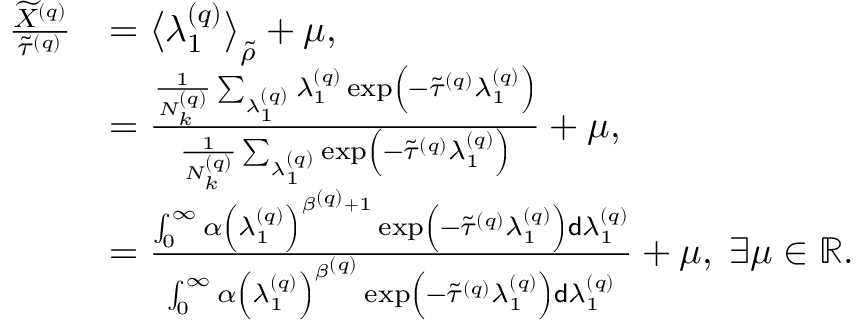<formula> <loc_0><loc_0><loc_500><loc_500>\begin{array} { r l } { \frac { \widetilde { X } ^ { \left ( q \right ) } } { \widetilde { \tau } ^ { \left ( q \right ) } } } & { = \left \langle \lambda _ { 1 } ^ { \left ( q \right ) } \right \rangle _ { \widetilde { \rho } } + \mu , } \\ & { = \frac { \frac { 1 } { N _ { k } ^ { \left ( q \right ) } } \sum _ { \lambda _ { 1 } ^ { \left ( q \right ) } } \lambda _ { 1 } ^ { \left ( q \right ) } \exp \left ( - \widetilde { \tau } ^ { \left ( q \right ) } \lambda _ { 1 } ^ { \left ( q \right ) } \right ) } { \frac { 1 } { N _ { k } ^ { \left ( q \right ) } } \sum _ { \lambda _ { 1 } ^ { \left ( q \right ) } } \exp \left ( - \widetilde { \tau } ^ { \left ( q \right ) } \lambda _ { 1 } ^ { \left ( q \right ) } \right ) } + \mu , } \\ & { = \frac { \int _ { 0 } ^ { \infty } \alpha \left ( \lambda _ { 1 } ^ { \left ( q \right ) } \right ) ^ { \beta ^ { \left ( q \right ) } + 1 } \exp \left ( - \widetilde { \tau } ^ { \left ( q \right ) } \lambda _ { 1 } ^ { \left ( q \right ) } \right ) d \lambda _ { 1 } ^ { \left ( q \right ) } } { \int _ { 0 } ^ { \infty } \alpha \left ( \lambda _ { 1 } ^ { \left ( q \right ) } \right ) ^ { \beta ^ { \left ( q \right ) } } \exp \left ( - \widetilde { \tau } ^ { \left ( q \right ) } \lambda _ { 1 } ^ { \left ( q \right ) } \right ) d \lambda _ { 1 } ^ { \left ( q \right ) } } + \mu , \, \exists \mu \in \mathbb { R } . } \end{array}</formula> 